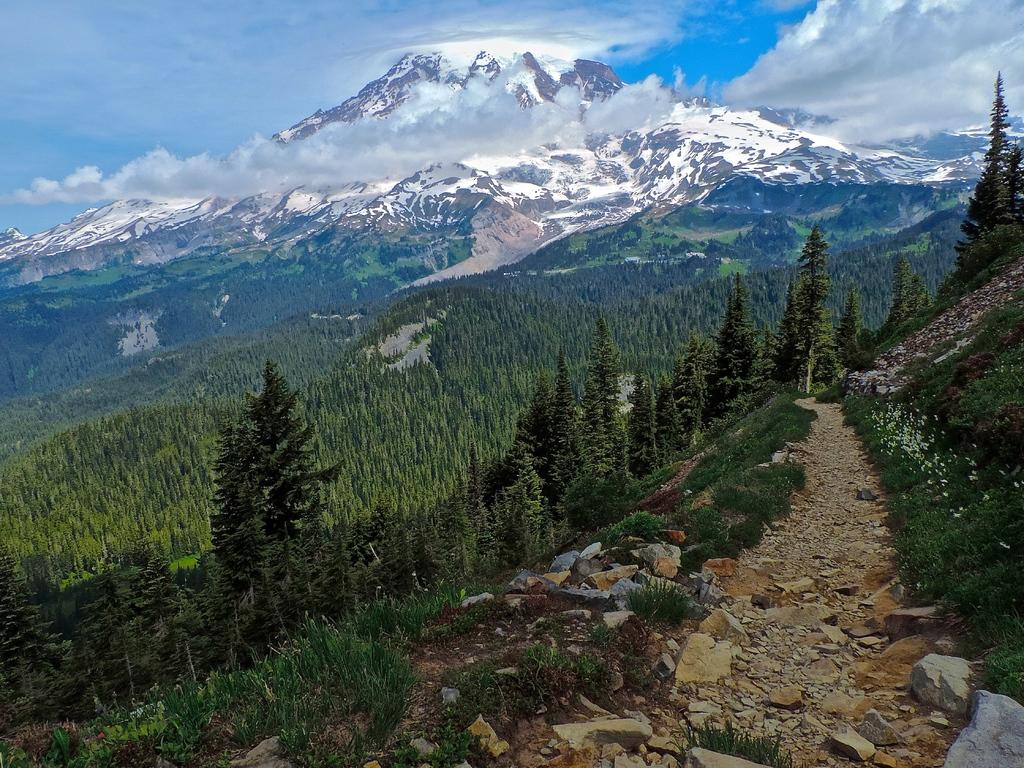What type of ground covering is visible in the image? The ground in the image is covered with grass. What other vegetation can be seen on the ground? There are plants on the ground. How many trees are present in the image? There are many trees in the image. What can be seen in the background of the image? There are mountains visible in the background. What is the condition of the mountains in the image? The mountains are covered with snow. Can you see any steam coming from the toy in the image? There is no toy present in the image, and therefore no steam can be seen. 